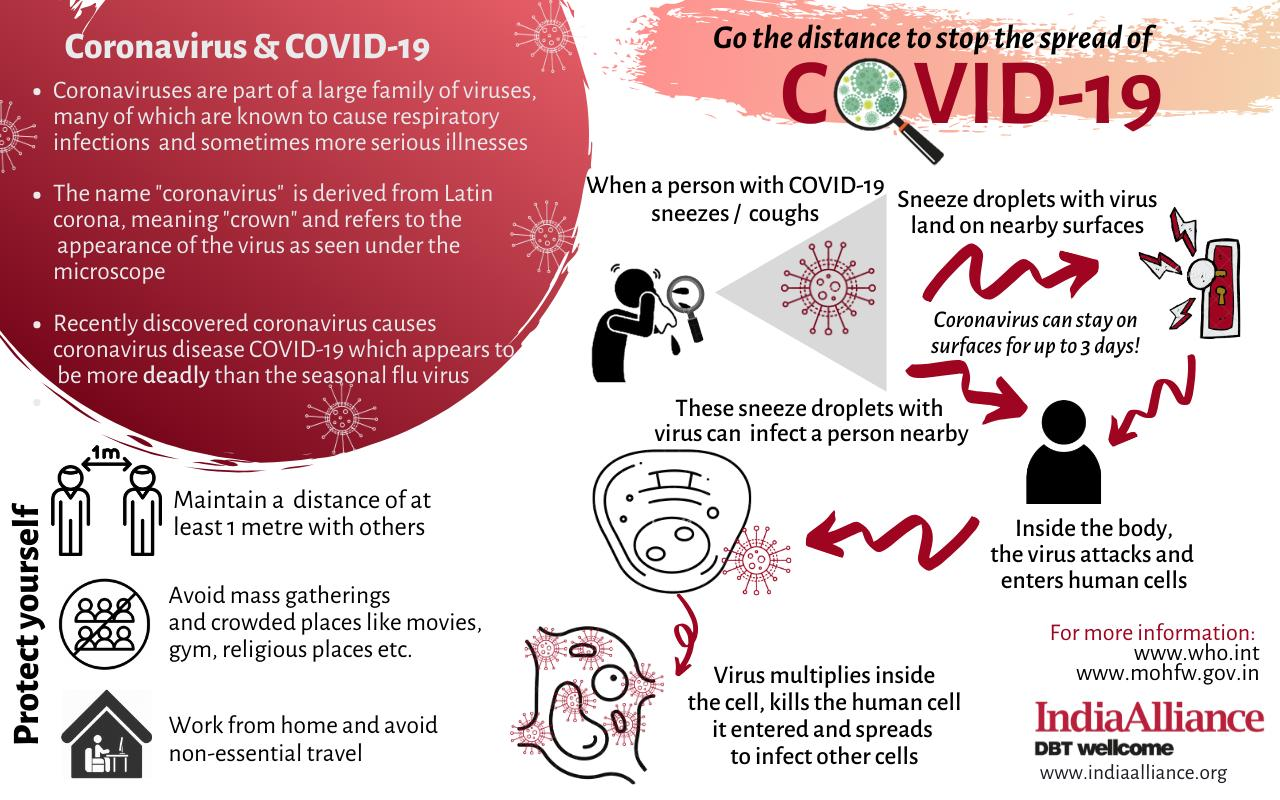Outline some significant characteristics in this image. The name of the virus family has been derived from the Latin language. The average survival time of the virus on surfaces is approximately 3 days, according to recent studies. The infographic lists 3 steps for self-protection. The virus family is known by its resemblance to a crown, which has been given its name by its distinct shape. 